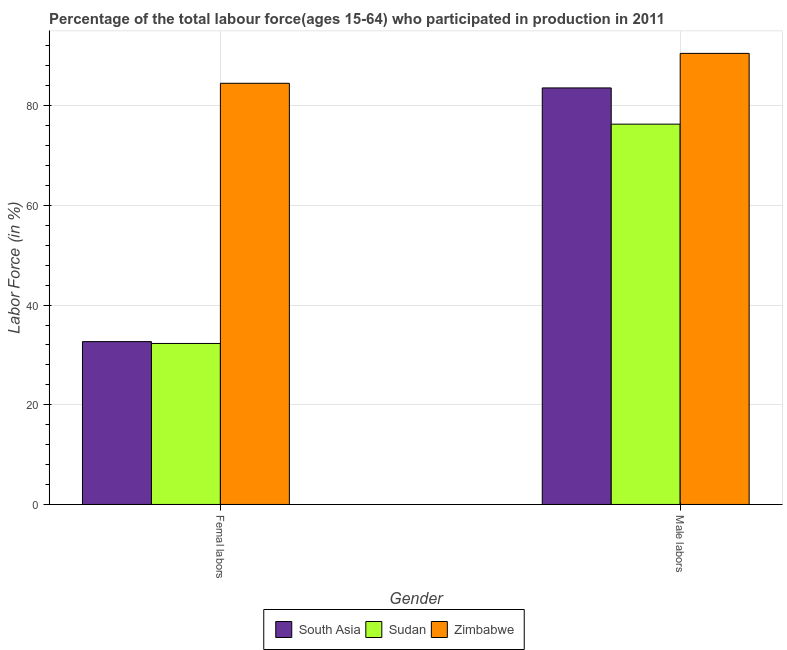How many groups of bars are there?
Give a very brief answer. 2. Are the number of bars per tick equal to the number of legend labels?
Provide a short and direct response. Yes. Are the number of bars on each tick of the X-axis equal?
Provide a short and direct response. Yes. How many bars are there on the 2nd tick from the right?
Offer a terse response. 3. What is the label of the 2nd group of bars from the left?
Your answer should be very brief. Male labors. What is the percentage of female labor force in Zimbabwe?
Give a very brief answer. 84.5. Across all countries, what is the maximum percentage of male labour force?
Make the answer very short. 90.5. Across all countries, what is the minimum percentage of male labour force?
Give a very brief answer. 76.3. In which country was the percentage of female labor force maximum?
Keep it short and to the point. Zimbabwe. In which country was the percentage of female labor force minimum?
Your answer should be compact. Sudan. What is the total percentage of male labour force in the graph?
Ensure brevity in your answer.  250.37. What is the difference between the percentage of female labor force in Sudan and that in South Asia?
Give a very brief answer. -0.37. What is the difference between the percentage of female labor force in Sudan and the percentage of male labour force in South Asia?
Keep it short and to the point. -51.27. What is the average percentage of male labour force per country?
Your answer should be compact. 83.46. What is the difference between the percentage of male labour force and percentage of female labor force in South Asia?
Keep it short and to the point. 50.9. In how many countries, is the percentage of female labor force greater than 40 %?
Your answer should be very brief. 1. What is the ratio of the percentage of female labor force in Sudan to that in Zimbabwe?
Provide a short and direct response. 0.38. What does the 1st bar from the left in Femal labors represents?
Offer a terse response. South Asia. What does the 3rd bar from the right in Male labors represents?
Make the answer very short. South Asia. How many bars are there?
Make the answer very short. 6. What is the difference between two consecutive major ticks on the Y-axis?
Keep it short and to the point. 20. Are the values on the major ticks of Y-axis written in scientific E-notation?
Your answer should be very brief. No. Does the graph contain any zero values?
Your response must be concise. No. How many legend labels are there?
Provide a short and direct response. 3. How are the legend labels stacked?
Your answer should be compact. Horizontal. What is the title of the graph?
Keep it short and to the point. Percentage of the total labour force(ages 15-64) who participated in production in 2011. Does "Canada" appear as one of the legend labels in the graph?
Offer a terse response. No. What is the Labor Force (in %) of South Asia in Femal labors?
Offer a very short reply. 32.67. What is the Labor Force (in %) of Sudan in Femal labors?
Provide a succinct answer. 32.3. What is the Labor Force (in %) in Zimbabwe in Femal labors?
Your response must be concise. 84.5. What is the Labor Force (in %) of South Asia in Male labors?
Provide a succinct answer. 83.57. What is the Labor Force (in %) in Sudan in Male labors?
Offer a very short reply. 76.3. What is the Labor Force (in %) in Zimbabwe in Male labors?
Ensure brevity in your answer.  90.5. Across all Gender, what is the maximum Labor Force (in %) of South Asia?
Your response must be concise. 83.57. Across all Gender, what is the maximum Labor Force (in %) of Sudan?
Offer a very short reply. 76.3. Across all Gender, what is the maximum Labor Force (in %) of Zimbabwe?
Offer a very short reply. 90.5. Across all Gender, what is the minimum Labor Force (in %) of South Asia?
Make the answer very short. 32.67. Across all Gender, what is the minimum Labor Force (in %) in Sudan?
Your answer should be very brief. 32.3. Across all Gender, what is the minimum Labor Force (in %) of Zimbabwe?
Keep it short and to the point. 84.5. What is the total Labor Force (in %) in South Asia in the graph?
Offer a terse response. 116.24. What is the total Labor Force (in %) in Sudan in the graph?
Give a very brief answer. 108.6. What is the total Labor Force (in %) in Zimbabwe in the graph?
Provide a short and direct response. 175. What is the difference between the Labor Force (in %) in South Asia in Femal labors and that in Male labors?
Provide a short and direct response. -50.9. What is the difference between the Labor Force (in %) of Sudan in Femal labors and that in Male labors?
Your answer should be compact. -44. What is the difference between the Labor Force (in %) of South Asia in Femal labors and the Labor Force (in %) of Sudan in Male labors?
Offer a very short reply. -43.63. What is the difference between the Labor Force (in %) in South Asia in Femal labors and the Labor Force (in %) in Zimbabwe in Male labors?
Keep it short and to the point. -57.83. What is the difference between the Labor Force (in %) of Sudan in Femal labors and the Labor Force (in %) of Zimbabwe in Male labors?
Your response must be concise. -58.2. What is the average Labor Force (in %) of South Asia per Gender?
Your answer should be very brief. 58.12. What is the average Labor Force (in %) in Sudan per Gender?
Keep it short and to the point. 54.3. What is the average Labor Force (in %) in Zimbabwe per Gender?
Make the answer very short. 87.5. What is the difference between the Labor Force (in %) of South Asia and Labor Force (in %) of Sudan in Femal labors?
Give a very brief answer. 0.37. What is the difference between the Labor Force (in %) in South Asia and Labor Force (in %) in Zimbabwe in Femal labors?
Your answer should be very brief. -51.83. What is the difference between the Labor Force (in %) of Sudan and Labor Force (in %) of Zimbabwe in Femal labors?
Provide a short and direct response. -52.2. What is the difference between the Labor Force (in %) of South Asia and Labor Force (in %) of Sudan in Male labors?
Make the answer very short. 7.27. What is the difference between the Labor Force (in %) of South Asia and Labor Force (in %) of Zimbabwe in Male labors?
Keep it short and to the point. -6.93. What is the ratio of the Labor Force (in %) in South Asia in Femal labors to that in Male labors?
Make the answer very short. 0.39. What is the ratio of the Labor Force (in %) in Sudan in Femal labors to that in Male labors?
Your answer should be very brief. 0.42. What is the ratio of the Labor Force (in %) in Zimbabwe in Femal labors to that in Male labors?
Offer a terse response. 0.93. What is the difference between the highest and the second highest Labor Force (in %) in South Asia?
Your answer should be compact. 50.9. What is the difference between the highest and the second highest Labor Force (in %) of Sudan?
Your response must be concise. 44. What is the difference between the highest and the lowest Labor Force (in %) in South Asia?
Provide a short and direct response. 50.9. What is the difference between the highest and the lowest Labor Force (in %) in Sudan?
Offer a terse response. 44. What is the difference between the highest and the lowest Labor Force (in %) in Zimbabwe?
Provide a short and direct response. 6. 